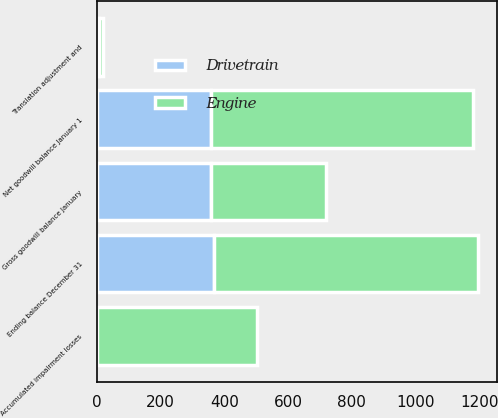Convert chart. <chart><loc_0><loc_0><loc_500><loc_500><stacked_bar_chart><ecel><fcel>Gross goodwill balance January<fcel>Accumulated impairment losses<fcel>Net goodwill balance January 1<fcel>Translation adjustment and<fcel>Ending balance December 31<nl><fcel>Engine<fcel>359.3<fcel>501.8<fcel>822.3<fcel>12.4<fcel>830.1<nl><fcel>Drivetrain<fcel>359.3<fcel>0.2<fcel>359.1<fcel>7.8<fcel>366.9<nl></chart> 